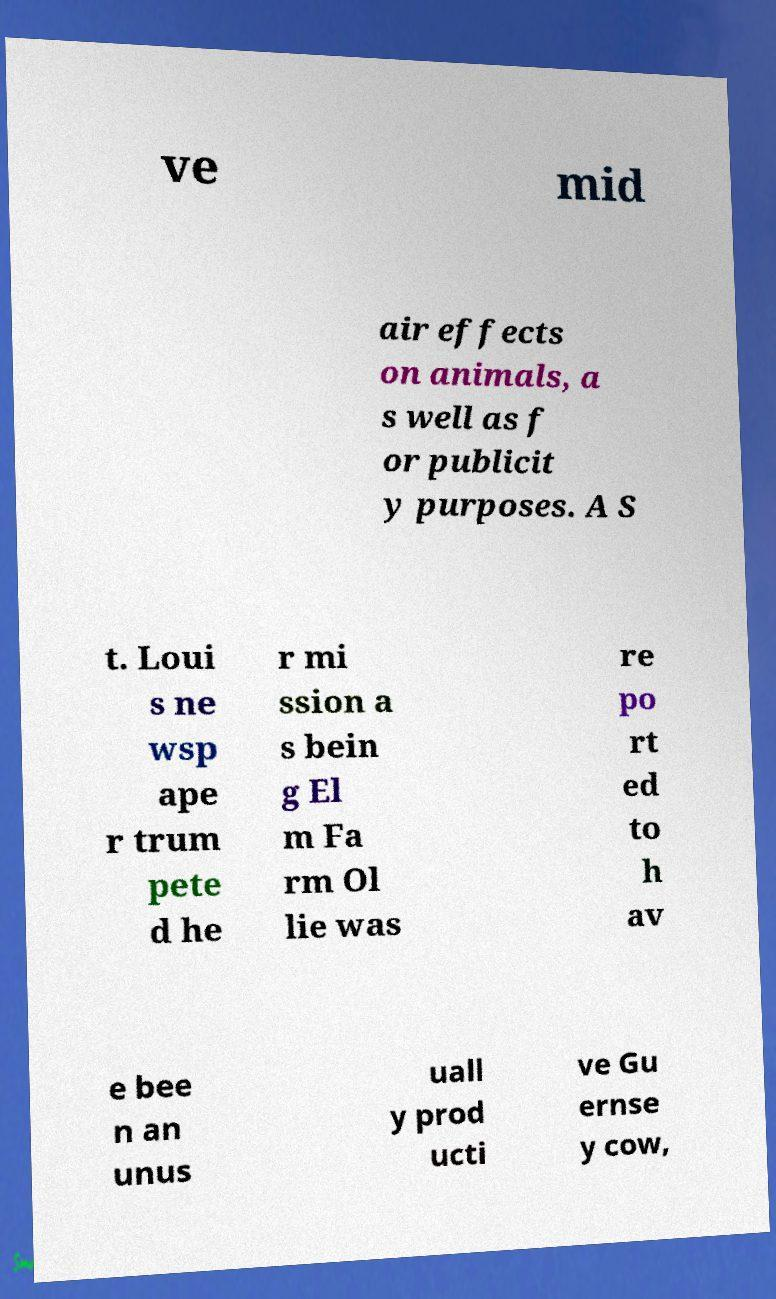Please identify and transcribe the text found in this image. ve mid air effects on animals, a s well as f or publicit y purposes. A S t. Loui s ne wsp ape r trum pete d he r mi ssion a s bein g El m Fa rm Ol lie was re po rt ed to h av e bee n an unus uall y prod ucti ve Gu ernse y cow, 